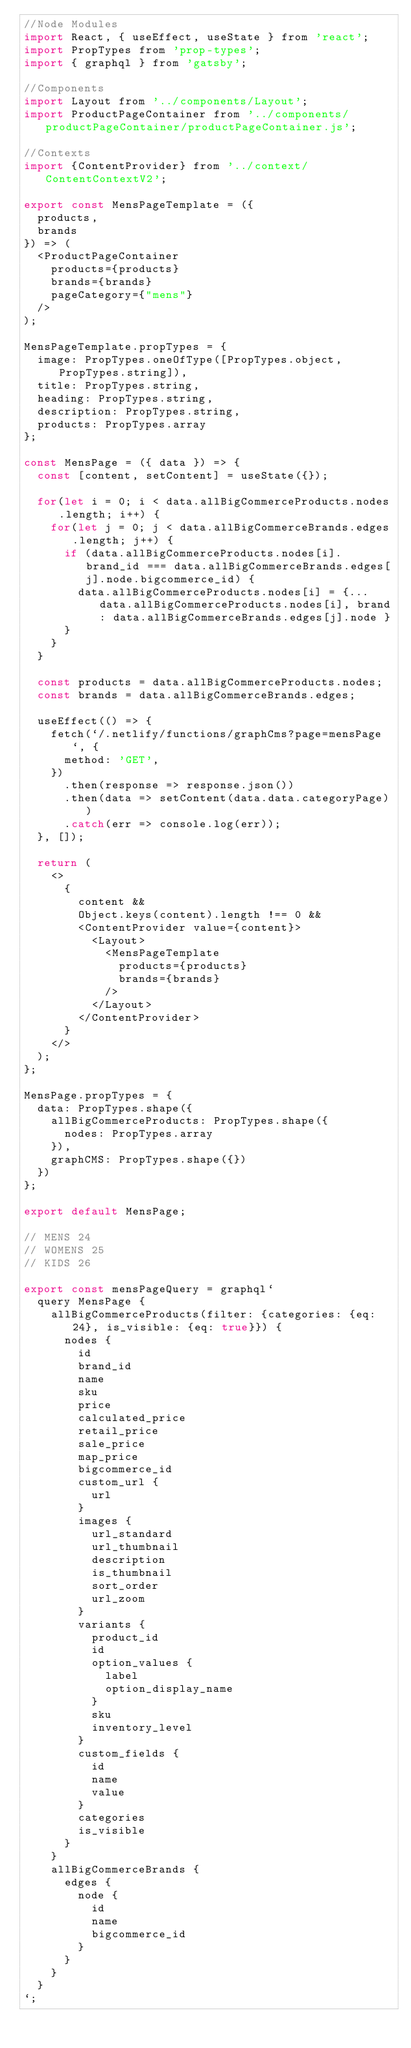Convert code to text. <code><loc_0><loc_0><loc_500><loc_500><_JavaScript_>//Node Modules
import React, { useEffect, useState } from 'react';
import PropTypes from 'prop-types';
import { graphql } from 'gatsby';

//Components
import Layout from '../components/Layout';
import ProductPageContainer from '../components/productPageContainer/productPageContainer.js';

//Contexts
import {ContentProvider} from '../context/ContentContextV2';

export const MensPageTemplate = ({
  products,
  brands
}) => (
  <ProductPageContainer
    products={products}
    brands={brands}
    pageCategory={"mens"}
  />
);

MensPageTemplate.propTypes = {
  image: PropTypes.oneOfType([PropTypes.object, PropTypes.string]),
  title: PropTypes.string,
  heading: PropTypes.string,
  description: PropTypes.string,
  products: PropTypes.array
};

const MensPage = ({ data }) => {
  const [content, setContent] = useState({});

  for(let i = 0; i < data.allBigCommerceProducts.nodes.length; i++) {
    for(let j = 0; j < data.allBigCommerceBrands.edges.length; j++) {
      if (data.allBigCommerceProducts.nodes[i].brand_id === data.allBigCommerceBrands.edges[j].node.bigcommerce_id) {
        data.allBigCommerceProducts.nodes[i] = {...data.allBigCommerceProducts.nodes[i], brand: data.allBigCommerceBrands.edges[j].node }
      }
    }
  }
  
  const products = data.allBigCommerceProducts.nodes;
  const brands = data.allBigCommerceBrands.edges;

  useEffect(() => {
    fetch(`/.netlify/functions/graphCms?page=mensPage`, {
      method: 'GET',
    })
      .then(response => response.json())
      .then(data => setContent(data.data.categoryPage))
      .catch(err => console.log(err));
  }, []);

  return (
    <>
      {
        content &&
        Object.keys(content).length !== 0 &&
        <ContentProvider value={content}>
          <Layout>
            <MensPageTemplate
              products={products}
              brands={brands}
            />
          </Layout>
        </ContentProvider>
      }
    </>
  );
};

MensPage.propTypes = {
  data: PropTypes.shape({
    allBigCommerceProducts: PropTypes.shape({
      nodes: PropTypes.array
    }),
    graphCMS: PropTypes.shape({})
  })
};

export default MensPage;

// MENS 24
// WOMENS 25
// KIDS 26

export const mensPageQuery = graphql`
  query MensPage {
    allBigCommerceProducts(filter: {categories: {eq: 24}, is_visible: {eq: true}}) {
      nodes {
        id
        brand_id
        name
        sku
        price
        calculated_price
        retail_price
        sale_price
        map_price
        bigcommerce_id
        custom_url {
          url
        }
        images {
          url_standard
          url_thumbnail
          description
          is_thumbnail
          sort_order
          url_zoom
        }
        variants {
          product_id
          id
          option_values {
            label
            option_display_name
          }
          sku
          inventory_level
        }
        custom_fields {
          id
          name
          value
        }
        categories
        is_visible
      }
    }
    allBigCommerceBrands {
      edges {
        node {
          id
          name
          bigcommerce_id
        }
      }
    }
  }
`;
</code> 